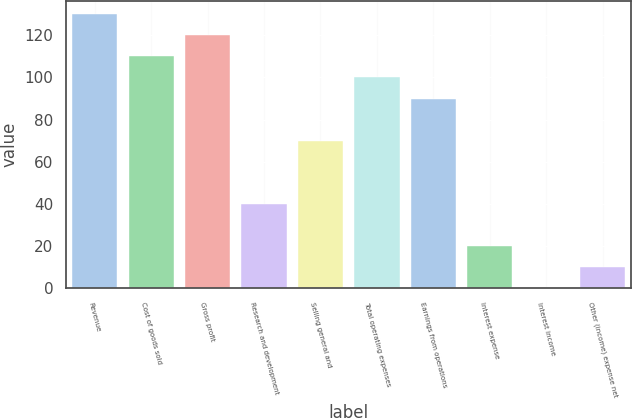<chart> <loc_0><loc_0><loc_500><loc_500><bar_chart><fcel>Revenue<fcel>Cost of goods sold<fcel>Gross profit<fcel>Research and development<fcel>Selling general and<fcel>Total operating expenses<fcel>Earnings from operations<fcel>Interest expense<fcel>Interest income<fcel>Other (income) expense net<nl><fcel>129.97<fcel>109.99<fcel>119.98<fcel>40.06<fcel>70.03<fcel>100<fcel>90.01<fcel>20.08<fcel>0.1<fcel>10.09<nl></chart> 